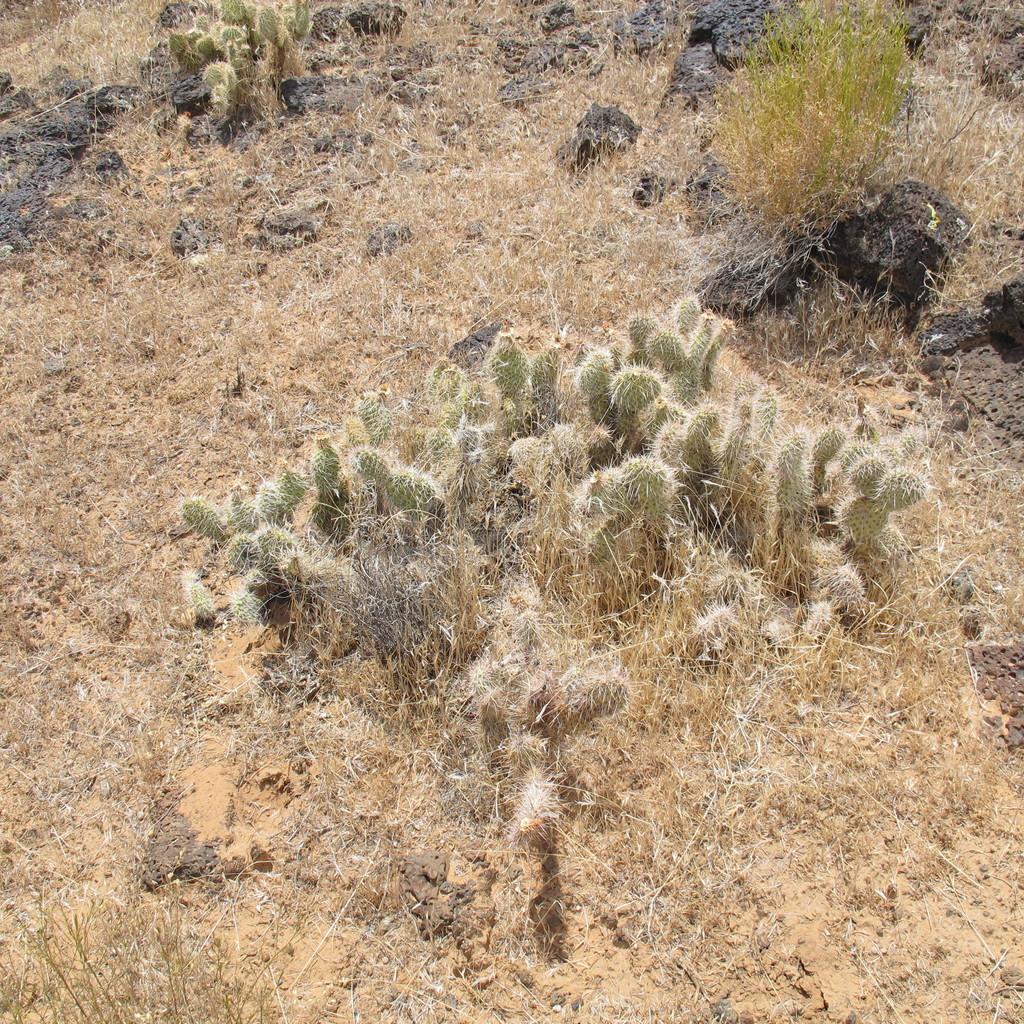Can you describe this image briefly? There are some cactus plants on a grassy land. 